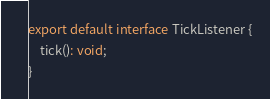<code> <loc_0><loc_0><loc_500><loc_500><_TypeScript_>
export default interface TickListener {
    tick(): void;
}</code> 